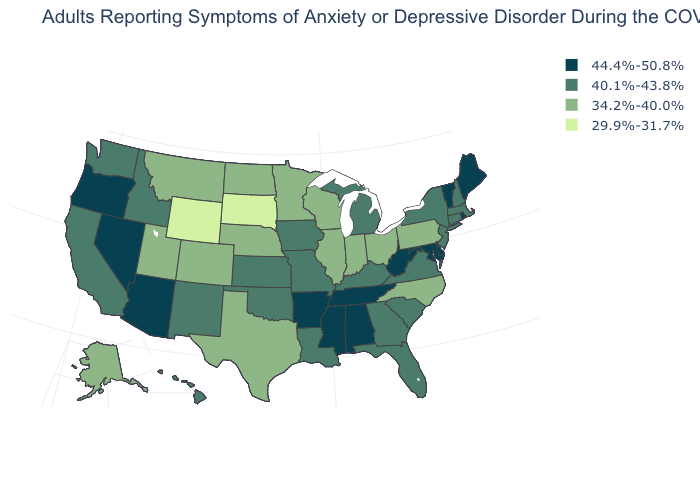Does Iowa have the highest value in the MidWest?
Be succinct. Yes. Does the first symbol in the legend represent the smallest category?
Concise answer only. No. What is the highest value in the USA?
Keep it brief. 44.4%-50.8%. Among the states that border Connecticut , which have the lowest value?
Give a very brief answer. Massachusetts, New York. What is the value of Oregon?
Answer briefly. 44.4%-50.8%. What is the value of New Jersey?
Write a very short answer. 40.1%-43.8%. Does Montana have the highest value in the USA?
Write a very short answer. No. Which states hav the highest value in the Northeast?
Write a very short answer. Maine, Rhode Island, Vermont. Is the legend a continuous bar?
Short answer required. No. What is the lowest value in states that border Wisconsin?
Give a very brief answer. 34.2%-40.0%. What is the highest value in states that border Colorado?
Give a very brief answer. 44.4%-50.8%. Name the states that have a value in the range 29.9%-31.7%?
Give a very brief answer. South Dakota, Wyoming. Name the states that have a value in the range 29.9%-31.7%?
Give a very brief answer. South Dakota, Wyoming. What is the value of Nebraska?
Short answer required. 34.2%-40.0%. 